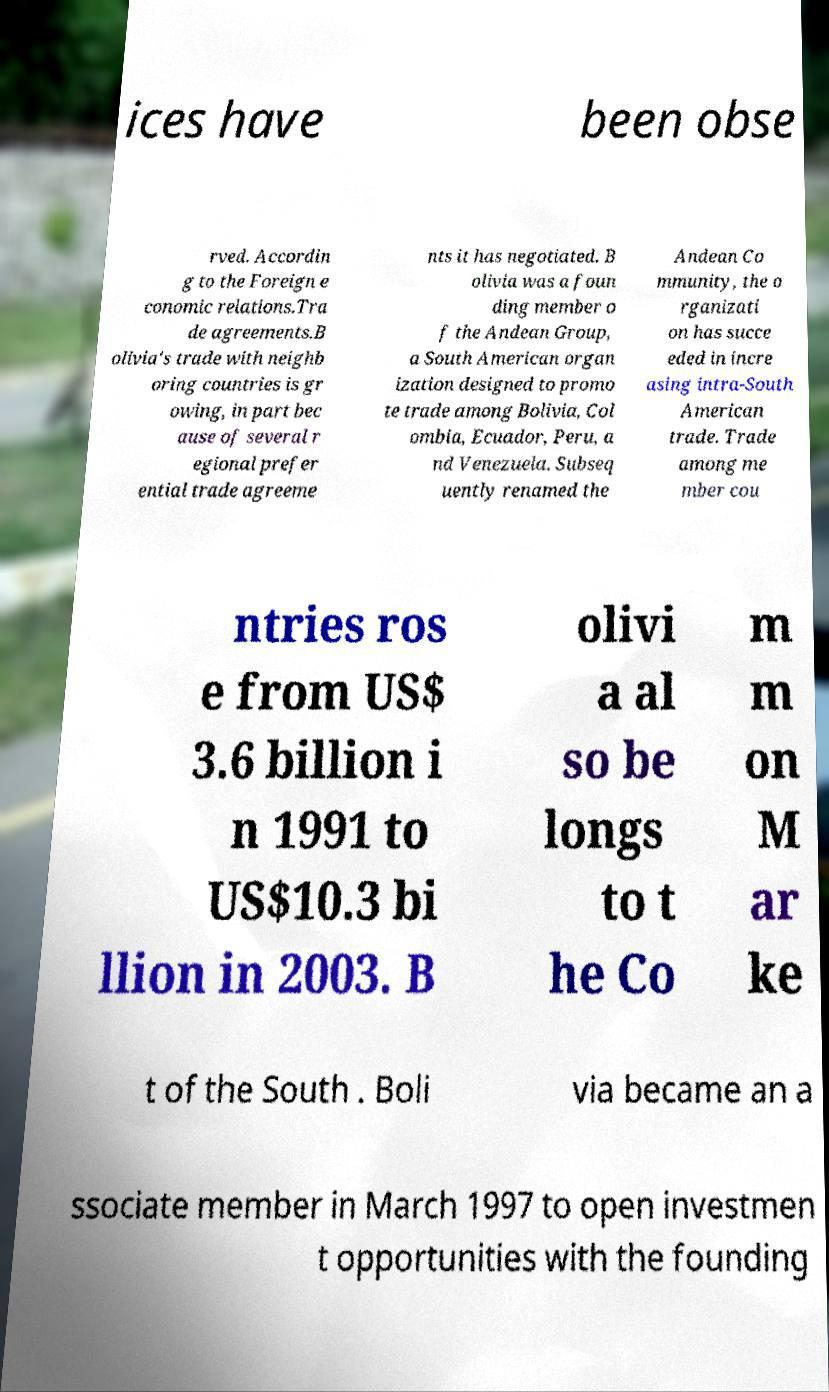For documentation purposes, I need the text within this image transcribed. Could you provide that? ices have been obse rved. Accordin g to the Foreign e conomic relations.Tra de agreements.B olivia's trade with neighb oring countries is gr owing, in part bec ause of several r egional prefer ential trade agreeme nts it has negotiated. B olivia was a foun ding member o f the Andean Group, a South American organ ization designed to promo te trade among Bolivia, Col ombia, Ecuador, Peru, a nd Venezuela. Subseq uently renamed the Andean Co mmunity, the o rganizati on has succe eded in incre asing intra-South American trade. Trade among me mber cou ntries ros e from US$ 3.6 billion i n 1991 to US$10.3 bi llion in 2003. B olivi a al so be longs to t he Co m m on M ar ke t of the South . Boli via became an a ssociate member in March 1997 to open investmen t opportunities with the founding 